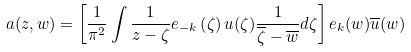<formula> <loc_0><loc_0><loc_500><loc_500>a ( z , w ) = \left [ \frac { 1 } { \pi ^ { 2 } } \int \frac { 1 } { z - \zeta } e _ { - k } \left ( \zeta \right ) u ( \zeta ) \frac { 1 } { \overline { \zeta } - \overline { w } } d \zeta \right ] e _ { k } ( w ) \overline { u } ( w )</formula> 